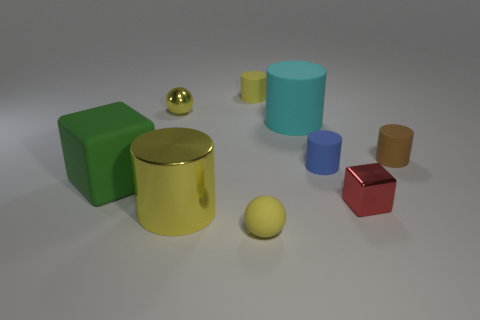Subtract all metal cylinders. How many cylinders are left? 4 Subtract 1 cylinders. How many cylinders are left? 4 Subtract all cyan cylinders. How many cylinders are left? 4 Add 1 tiny brown metal objects. How many objects exist? 10 Subtract all cyan cylinders. Subtract all brown blocks. How many cylinders are left? 4 Subtract all balls. How many objects are left? 7 Add 7 small yellow matte objects. How many small yellow matte objects exist? 9 Subtract 2 yellow cylinders. How many objects are left? 7 Subtract all brown matte cylinders. Subtract all large cyan cylinders. How many objects are left? 7 Add 4 large matte cubes. How many large matte cubes are left? 5 